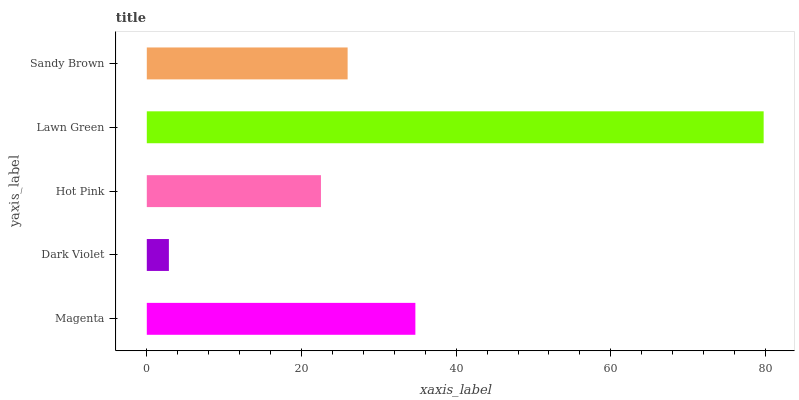Is Dark Violet the minimum?
Answer yes or no. Yes. Is Lawn Green the maximum?
Answer yes or no. Yes. Is Hot Pink the minimum?
Answer yes or no. No. Is Hot Pink the maximum?
Answer yes or no. No. Is Hot Pink greater than Dark Violet?
Answer yes or no. Yes. Is Dark Violet less than Hot Pink?
Answer yes or no. Yes. Is Dark Violet greater than Hot Pink?
Answer yes or no. No. Is Hot Pink less than Dark Violet?
Answer yes or no. No. Is Sandy Brown the high median?
Answer yes or no. Yes. Is Sandy Brown the low median?
Answer yes or no. Yes. Is Hot Pink the high median?
Answer yes or no. No. Is Hot Pink the low median?
Answer yes or no. No. 